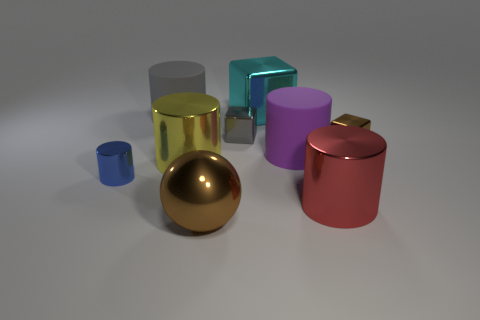Subtract all large purple rubber cylinders. How many cylinders are left? 4 Subtract all yellow cylinders. How many cylinders are left? 4 Subtract all cyan cylinders. Subtract all red balls. How many cylinders are left? 5 Add 1 yellow cylinders. How many objects exist? 10 Subtract all balls. How many objects are left? 8 Add 5 yellow metal objects. How many yellow metal objects are left? 6 Add 4 purple things. How many purple things exist? 5 Subtract 0 green cylinders. How many objects are left? 9 Subtract all purple matte things. Subtract all small brown rubber cubes. How many objects are left? 8 